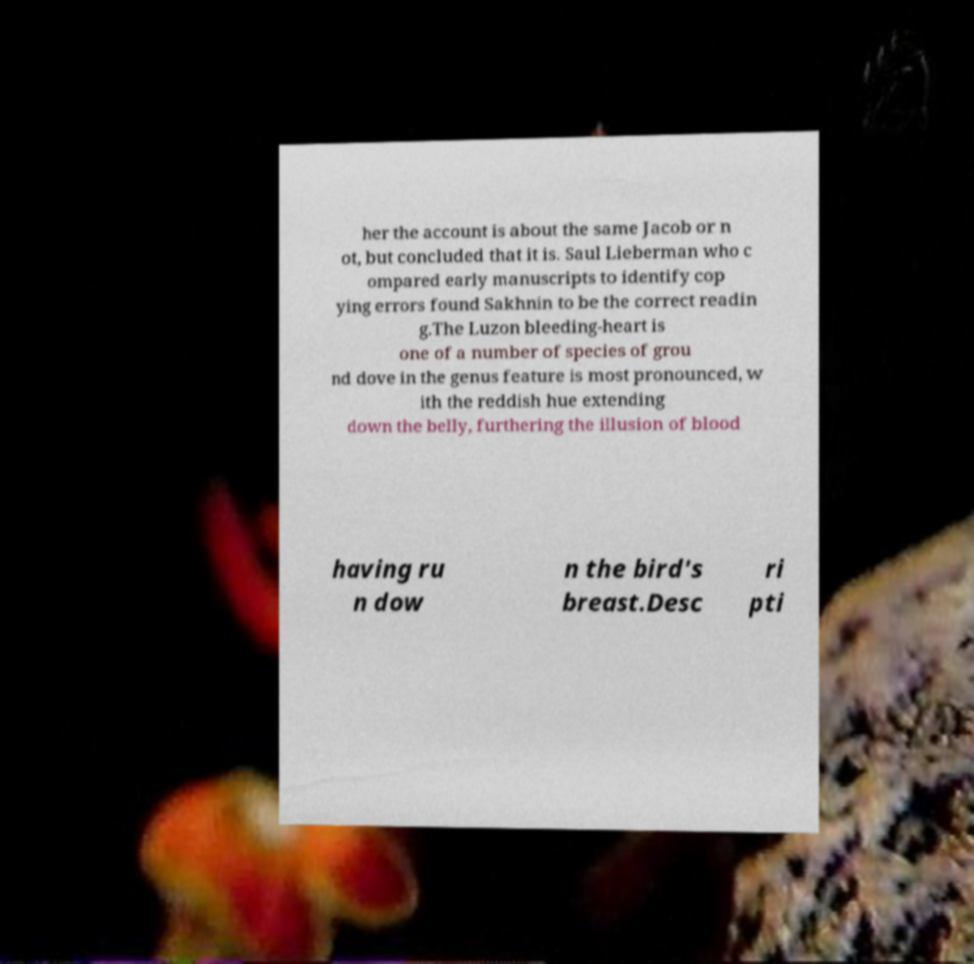Please read and relay the text visible in this image. What does it say? her the account is about the same Jacob or n ot, but concluded that it is. Saul Lieberman who c ompared early manuscripts to identify cop ying errors found Sakhnin to be the correct readin g.The Luzon bleeding-heart is one of a number of species of grou nd dove in the genus feature is most pronounced, w ith the reddish hue extending down the belly, furthering the illusion of blood having ru n dow n the bird's breast.Desc ri pti 